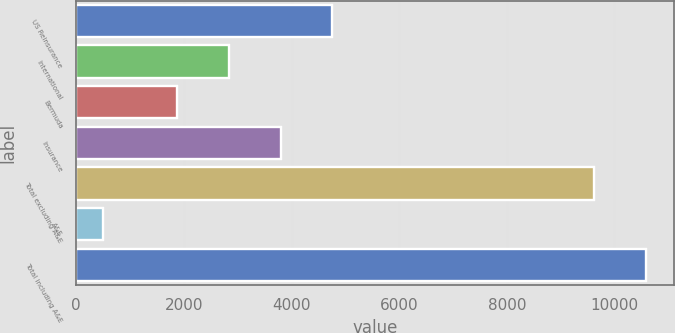Convert chart to OTSL. <chart><loc_0><loc_0><loc_500><loc_500><bar_chart><fcel>US Reinsurance<fcel>International<fcel>Bermuda<fcel>Insurance<fcel>Total excluding A&E<fcel>A&E<fcel>Total including A&E<nl><fcel>4759.59<fcel>2834.93<fcel>1872.6<fcel>3797.26<fcel>9623.3<fcel>499.9<fcel>10585.6<nl></chart> 